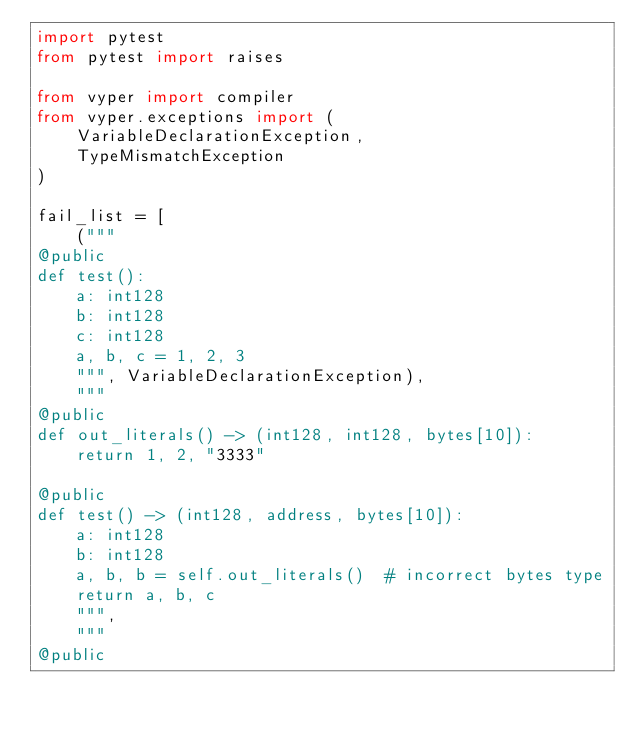<code> <loc_0><loc_0><loc_500><loc_500><_Python_>import pytest
from pytest import raises

from vyper import compiler
from vyper.exceptions import (
    VariableDeclarationException,
    TypeMismatchException
)

fail_list = [
    ("""
@public
def test():
    a: int128
    b: int128
    c: int128
    a, b, c = 1, 2, 3
    """, VariableDeclarationException),
    """
@public
def out_literals() -> (int128, int128, bytes[10]):
    return 1, 2, "3333"

@public
def test() -> (int128, address, bytes[10]):
    a: int128
    b: int128
    a, b, b = self.out_literals()  # incorrect bytes type
    return a, b, c
    """,
    """
@public</code> 